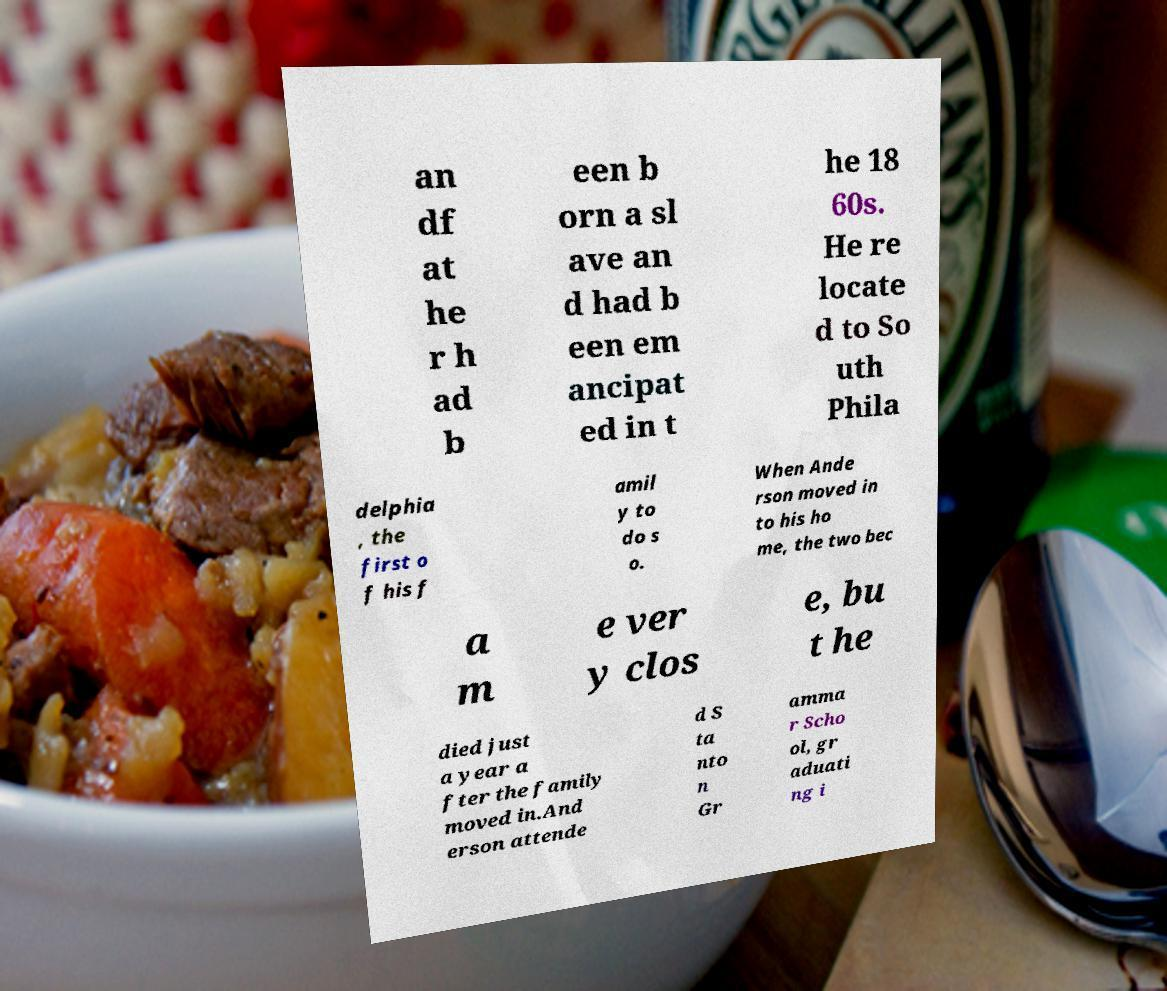Can you read and provide the text displayed in the image?This photo seems to have some interesting text. Can you extract and type it out for me? an df at he r h ad b een b orn a sl ave an d had b een em ancipat ed in t he 18 60s. He re locate d to So uth Phila delphia , the first o f his f amil y to do s o. When Ande rson moved in to his ho me, the two bec a m e ver y clos e, bu t he died just a year a fter the family moved in.And erson attende d S ta nto n Gr amma r Scho ol, gr aduati ng i 